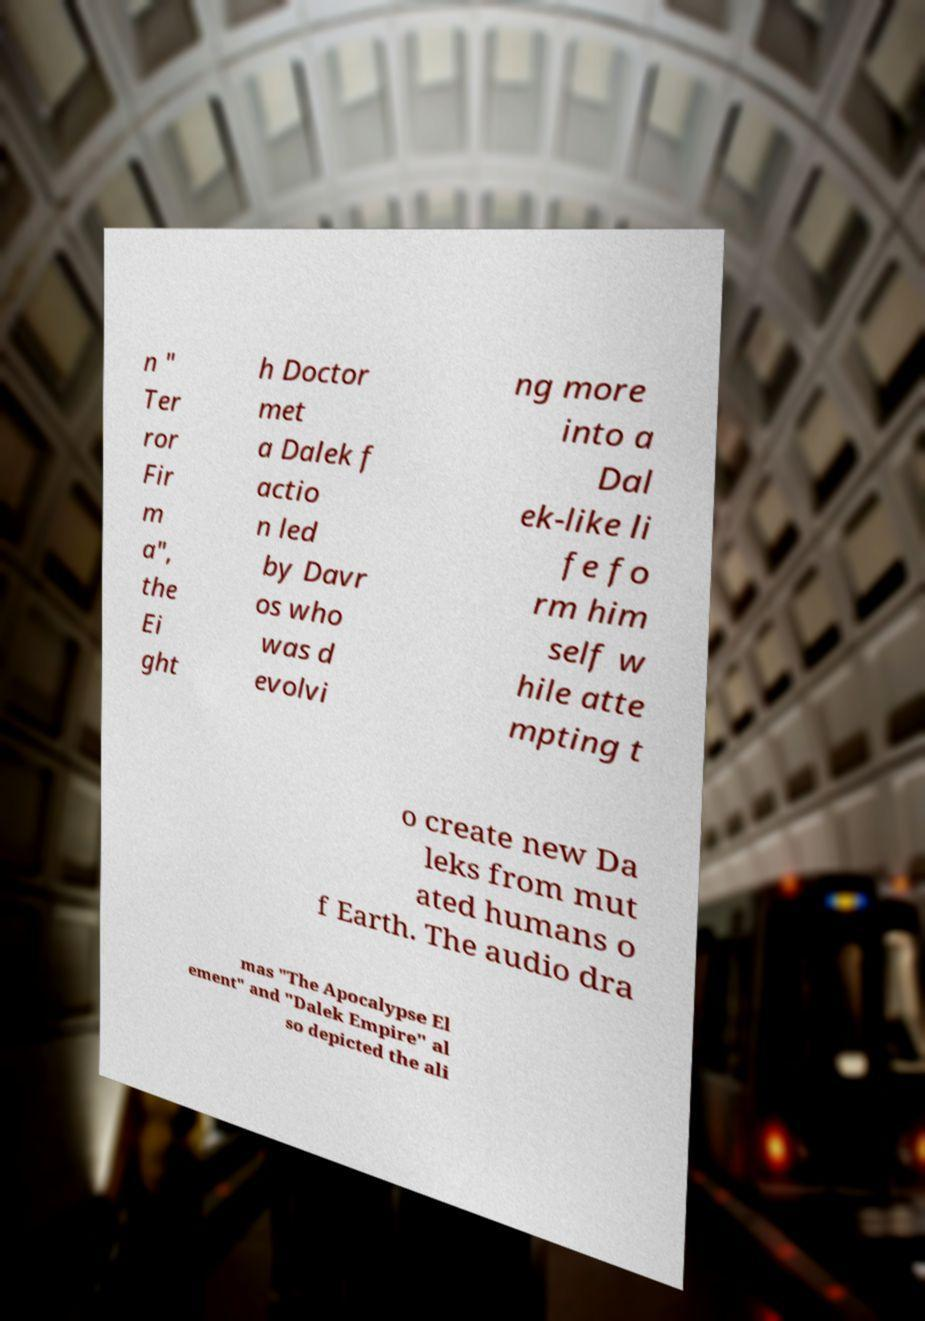Please identify and transcribe the text found in this image. n " Ter ror Fir m a", the Ei ght h Doctor met a Dalek f actio n led by Davr os who was d evolvi ng more into a Dal ek-like li fe fo rm him self w hile atte mpting t o create new Da leks from mut ated humans o f Earth. The audio dra mas "The Apocalypse El ement" and "Dalek Empire" al so depicted the ali 